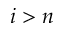<formula> <loc_0><loc_0><loc_500><loc_500>i > n</formula> 